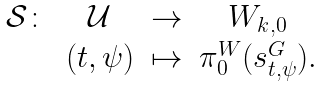Convert formula to latex. <formula><loc_0><loc_0><loc_500><loc_500>\begin{array} { r c c c } \mathcal { S } \colon & \mathcal { U } & \rightarrow & W _ { k , 0 } \\ & ( t , \psi ) & \mapsto & \pi ^ { W } _ { 0 } ( s ^ { G } _ { t , \psi } ) . \end{array}</formula> 